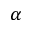Convert formula to latex. <formula><loc_0><loc_0><loc_500><loc_500>\alpha</formula> 